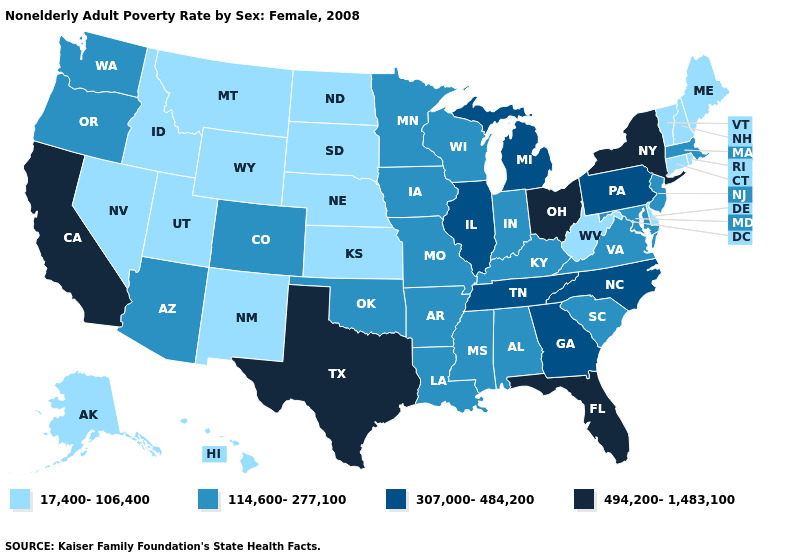Does Maryland have a lower value than Florida?
Be succinct. Yes. What is the lowest value in the USA?
Short answer required. 17,400-106,400. Name the states that have a value in the range 17,400-106,400?
Concise answer only. Alaska, Connecticut, Delaware, Hawaii, Idaho, Kansas, Maine, Montana, Nebraska, Nevada, New Hampshire, New Mexico, North Dakota, Rhode Island, South Dakota, Utah, Vermont, West Virginia, Wyoming. Does New York have the highest value in the USA?
Be succinct. Yes. Is the legend a continuous bar?
Be succinct. No. What is the highest value in the South ?
Give a very brief answer. 494,200-1,483,100. What is the value of Arkansas?
Keep it brief. 114,600-277,100. Name the states that have a value in the range 114,600-277,100?
Keep it brief. Alabama, Arizona, Arkansas, Colorado, Indiana, Iowa, Kentucky, Louisiana, Maryland, Massachusetts, Minnesota, Mississippi, Missouri, New Jersey, Oklahoma, Oregon, South Carolina, Virginia, Washington, Wisconsin. Which states hav the highest value in the Northeast?
Quick response, please. New York. Which states have the lowest value in the USA?
Be succinct. Alaska, Connecticut, Delaware, Hawaii, Idaho, Kansas, Maine, Montana, Nebraska, Nevada, New Hampshire, New Mexico, North Dakota, Rhode Island, South Dakota, Utah, Vermont, West Virginia, Wyoming. Name the states that have a value in the range 494,200-1,483,100?
Concise answer only. California, Florida, New York, Ohio, Texas. Name the states that have a value in the range 17,400-106,400?
Quick response, please. Alaska, Connecticut, Delaware, Hawaii, Idaho, Kansas, Maine, Montana, Nebraska, Nevada, New Hampshire, New Mexico, North Dakota, Rhode Island, South Dakota, Utah, Vermont, West Virginia, Wyoming. Name the states that have a value in the range 494,200-1,483,100?
Quick response, please. California, Florida, New York, Ohio, Texas. What is the highest value in the USA?
Short answer required. 494,200-1,483,100. What is the value of North Carolina?
Concise answer only. 307,000-484,200. 